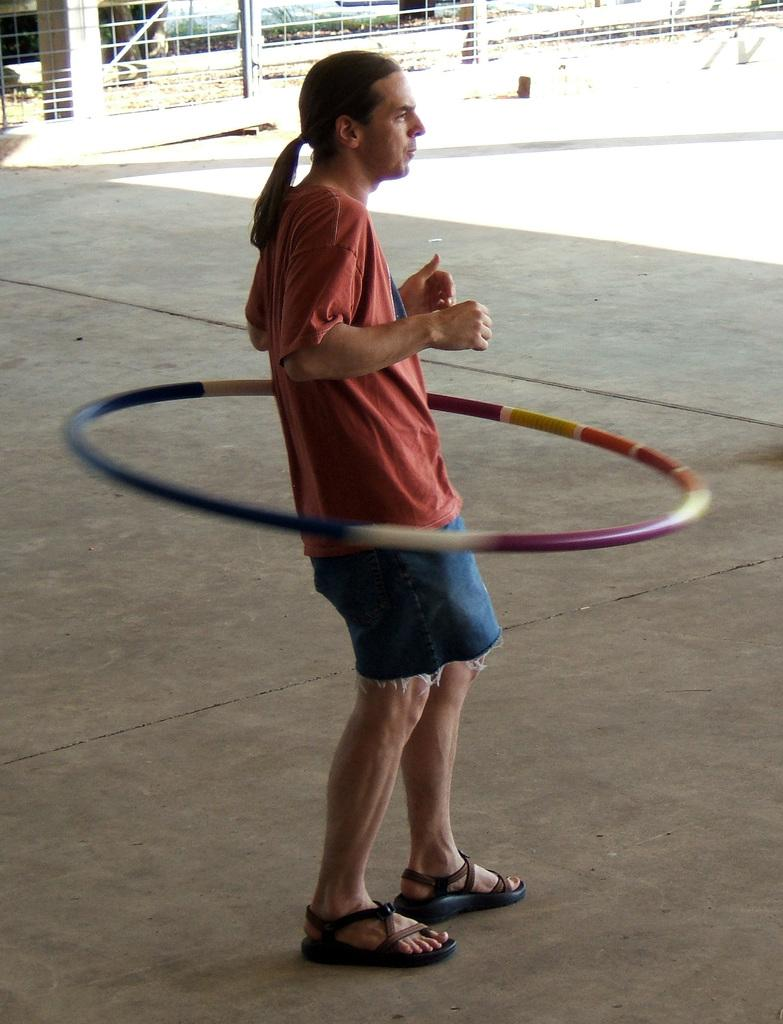What is the man in the image doing? The man is rotating a ring around him. What is the man standing on in the image? The man is standing on a floor. What can be seen in the background of the image? There is a wall and a railing in the background of the image. What type of potato is visible in the image? There is no potato present in the image. How many ghosts can be seen interacting with the man in the image? There are no ghosts present in the image; it only features the man and the ring he is rotating. 